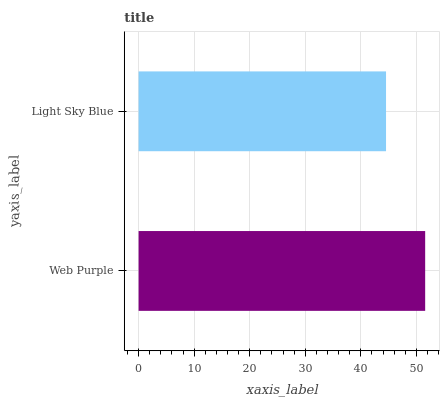Is Light Sky Blue the minimum?
Answer yes or no. Yes. Is Web Purple the maximum?
Answer yes or no. Yes. Is Light Sky Blue the maximum?
Answer yes or no. No. Is Web Purple greater than Light Sky Blue?
Answer yes or no. Yes. Is Light Sky Blue less than Web Purple?
Answer yes or no. Yes. Is Light Sky Blue greater than Web Purple?
Answer yes or no. No. Is Web Purple less than Light Sky Blue?
Answer yes or no. No. Is Web Purple the high median?
Answer yes or no. Yes. Is Light Sky Blue the low median?
Answer yes or no. Yes. Is Light Sky Blue the high median?
Answer yes or no. No. Is Web Purple the low median?
Answer yes or no. No. 